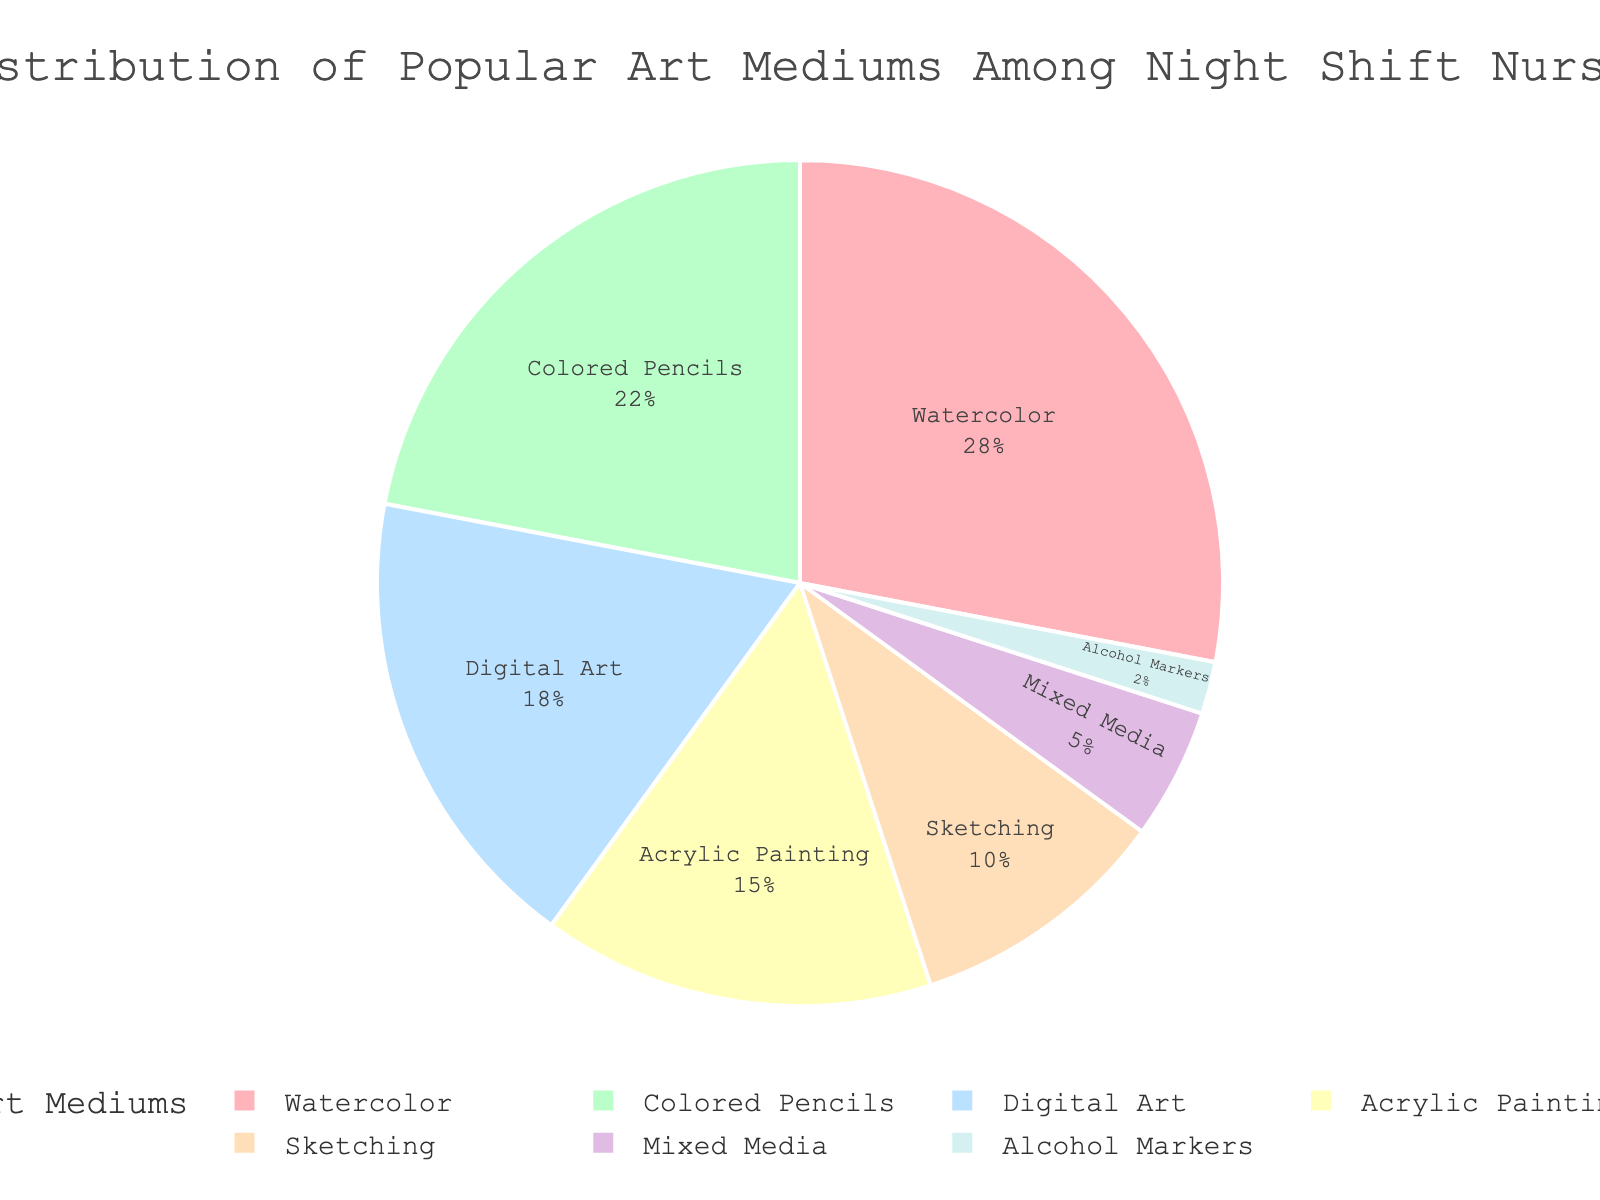what is the most popular art medium among night shift nurses? The most popular art medium captures the highest percentage in the pie chart. Here, Watercolor, being the largest slice, has 28%.
Answer: Watercolor What is the cumulative percentage for Sketching, Mixed Media, and Alcohol Markers combined? Sum the percentages for Sketching (10%), Mixed Media (5%), and Alcohol Markers (2%). 10 + 5 + 2 = 17%
Answer: 17% Which art medium accounts for twice the percentage of Sketching? Identify the percentage for Sketching, which is 10%. The medium with a percentage twice this value is Watercolor at 28%
Answer: None have twice of Sketching Between Digital Art and Acrylic Painting, which medium is more preferred by night shift nurses? Compare the percentages of Digital Art (18%) and Acrylic Painting (15%) from the chart. Digital Art has a larger percentage.
Answer: Digital Art How much higher is the percentage of Colored Pencils compared to Alcohol Markers? Calculate the difference between the percentages of Colored Pencils (22%) and Alcohol Markers (2%). The difference is 22 - 2 = 20%
Answer: 20% What is the average percentage of the four least popular mediums? Identify the four least popular mediums: Sketching (10%), Mixed Media (5%), Alcohol Markers (2%), and Acrylic Painting (15%). Sum these percentages and divide by 4: (10 + 5 + 2 + 15) / 4 = 8%
Answer: 8% If we group Digital Art and Acrylic Painting together, what percentage do they represent? Add the percentages of Digital Art (18%) and Acrylic Painting (15%). The combined percentage is 18 + 15 = 33%
Answer: 33% What percentage of night shift nurses prefer traditional methods (Watercolor, Colored Pencils, Sketching) over digital methods? Sum the percentages of Watercolor, Colored Pencils, and Sketching which represent traditional methods: 28 + 22 + 10 = 60%. Digital Art represents 18%. Traditional methods: 60%
Answer: 60% For Sketching and Mixed Media, what is the ratio of their percentages? Divide the percentage of Sketching (10%) by that of Mixed Media (5%). The ratio is 10 / 5 = 2:1
Answer: 2:1 